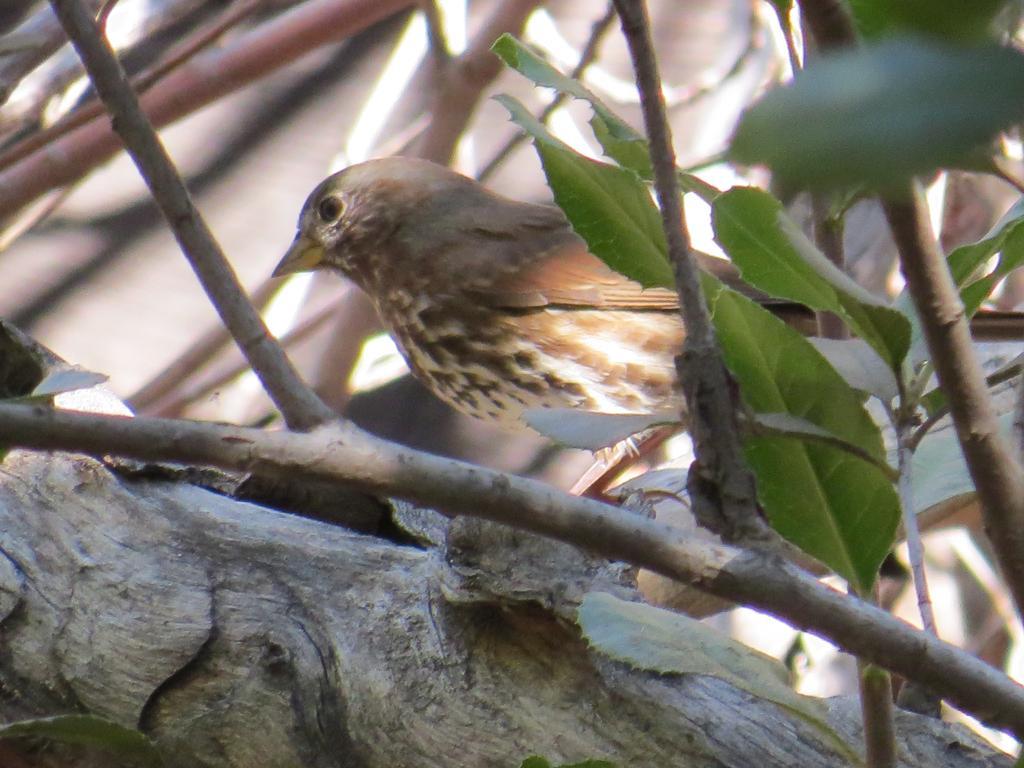Can you describe this image briefly? In this image, this looks like a bird, which is standing. These are the branches and the leaves. 